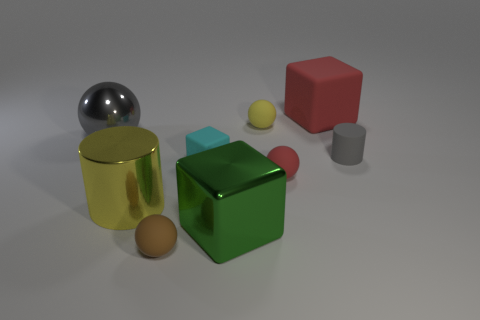Does the rubber cylinder have the same color as the big ball?
Your answer should be compact. Yes. There is a matte cube that is the same size as the shiny cylinder; what color is it?
Provide a short and direct response. Red. What number of yellow things are either tiny matte things or shiny cylinders?
Provide a succinct answer. 2. Is the number of small red matte spheres greater than the number of rubber objects?
Ensure brevity in your answer.  No. There is a cylinder that is in front of the small cyan block; is it the same size as the rubber thing that is in front of the tiny red ball?
Give a very brief answer. No. There is a large object right of the ball behind the gray thing on the left side of the tiny red rubber thing; what color is it?
Make the answer very short. Red. Are there any cyan rubber objects that have the same shape as the large yellow thing?
Make the answer very short. No. Are there more matte things in front of the large cylinder than small blue rubber cubes?
Provide a succinct answer. Yes. What number of rubber objects are large gray balls or small gray cylinders?
Provide a succinct answer. 1. How big is the ball that is both to the left of the green metal object and behind the large cylinder?
Offer a very short reply. Large. 